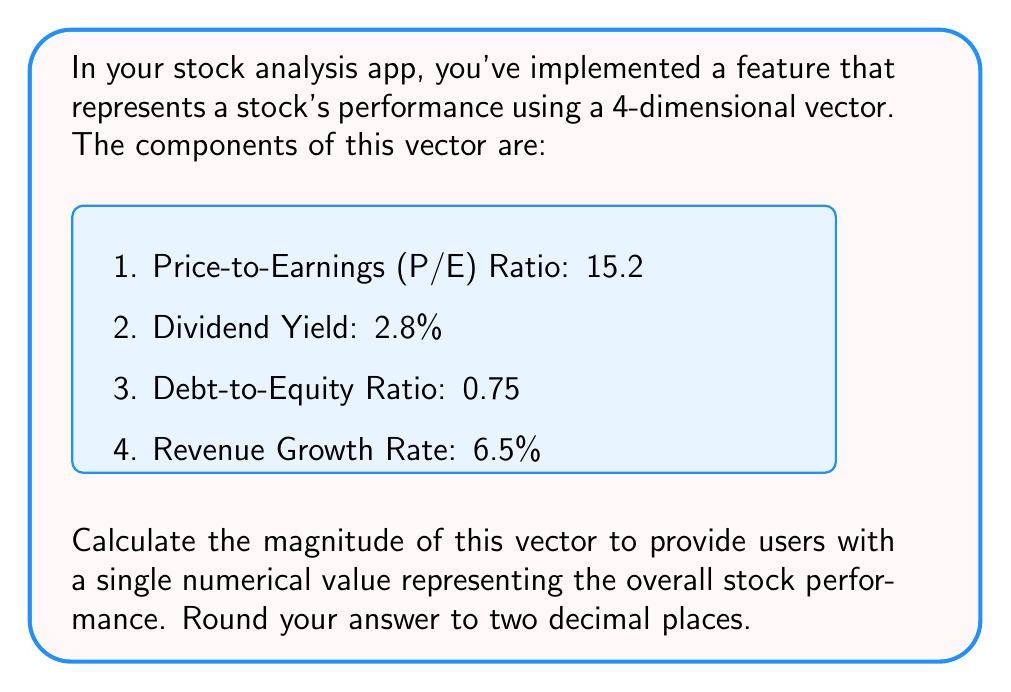Solve this math problem. To calculate the magnitude of a vector, we use the Euclidean norm formula:

$$\text{Magnitude} = \sqrt{x_1^2 + x_2^2 + x_3^2 + x_4^2}$$

Where $x_1, x_2, x_3,$ and $x_4$ are the components of the vector.

Let's substitute the values:

1. $x_1 = 15.2$ (P/E Ratio)
2. $x_2 = 2.8$ (Dividend Yield)
3. $x_3 = 0.75$ (Debt-to-Equity Ratio)
4. $x_4 = 6.5$ (Revenue Growth Rate)

Now, let's calculate:

$$\begin{align}
\text{Magnitude} &= \sqrt{15.2^2 + 2.8^2 + 0.75^2 + 6.5^2} \\[10pt]
&= \sqrt{231.04 + 7.84 + 0.5625 + 42.25} \\[10pt]
&= \sqrt{281.6925} \\[10pt]
&= 16.7836...
\end{align}$$

Rounding to two decimal places:

$$\text{Magnitude} \approx 16.78$$
Answer: 16.78 